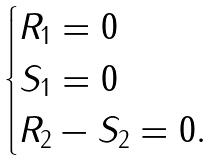<formula> <loc_0><loc_0><loc_500><loc_500>\begin{cases} R _ { 1 } = 0 \\ S _ { 1 } = 0 \\ R _ { 2 } - S _ { 2 } = 0 . \end{cases}</formula> 